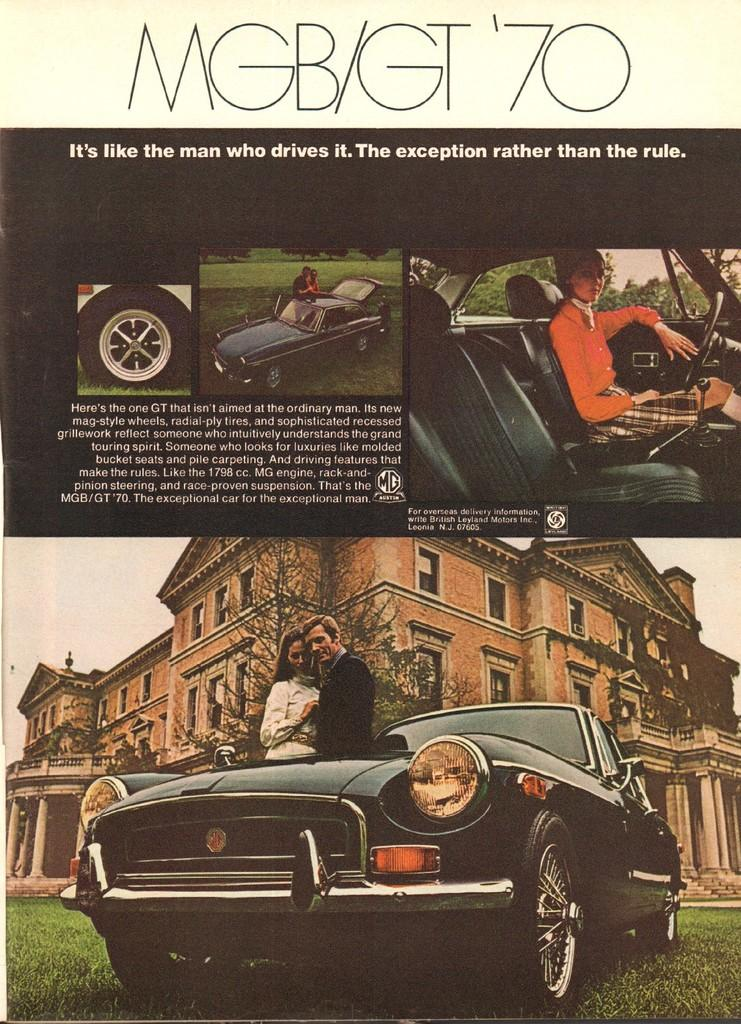What is the main object in the image? There is a pamphlet in the image. What is depicted on the pamphlet? The pamphlet contains an image of a vehicle. How many people are in the image? There are two persons standing in the image. What is the color of the building in the image? There is a building with a brown color in the image. Can you describe the scene involving a car in the image? There is a person sitting in a car in the image. What color is the good-bye wave in the image? There is no good-bye wave present in the image. What type of front is visible in the image? There is no specific front mentioned or visible in the image. 